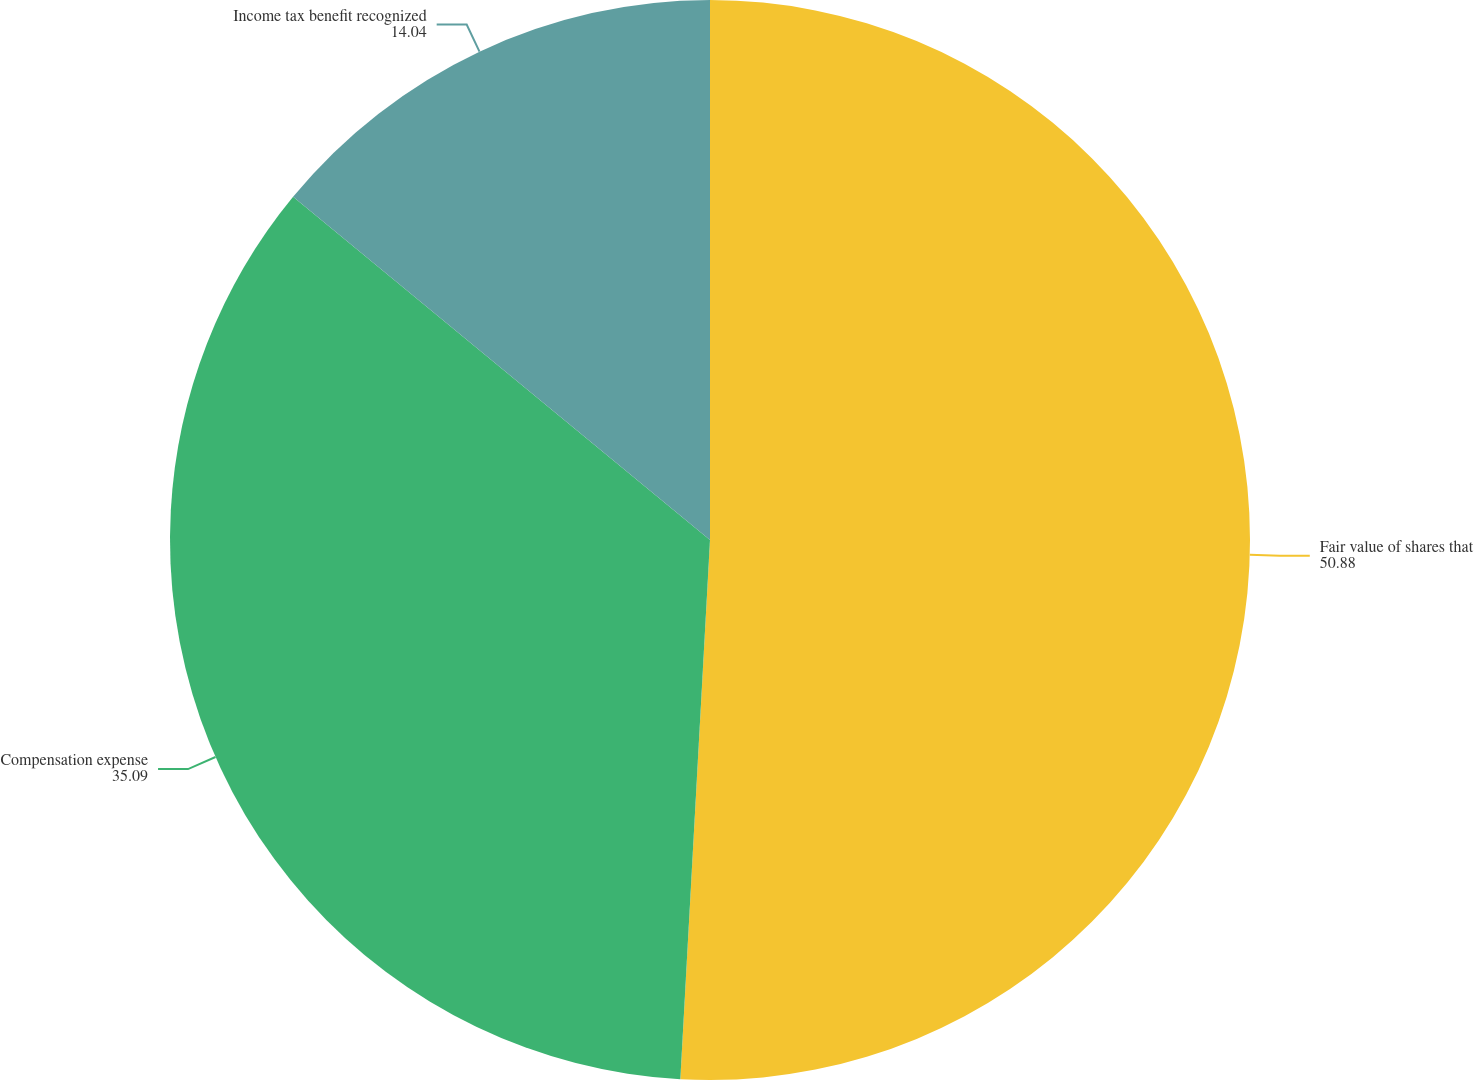<chart> <loc_0><loc_0><loc_500><loc_500><pie_chart><fcel>Fair value of shares that<fcel>Compensation expense<fcel>Income tax benefit recognized<nl><fcel>50.88%<fcel>35.09%<fcel>14.04%<nl></chart> 